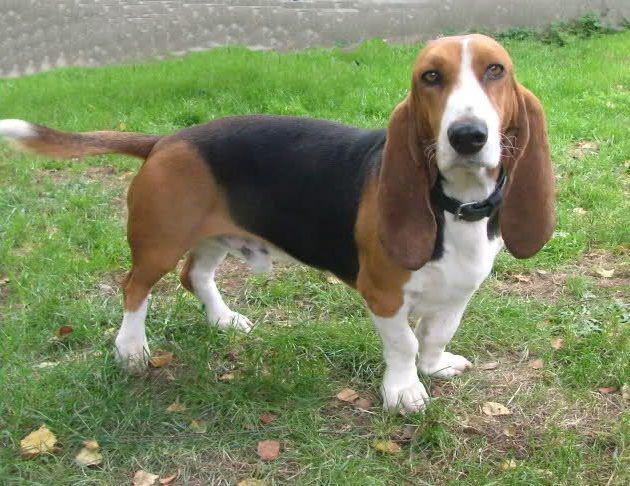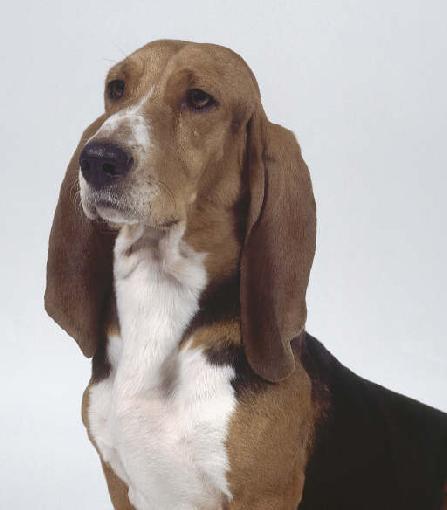The first image is the image on the left, the second image is the image on the right. Assess this claim about the two images: "there is a beagle outside on the grass". Correct or not? Answer yes or no. Yes. The first image is the image on the left, the second image is the image on the right. For the images displayed, is the sentence "Each image shows one standing basset hound, and one image includes a person with hands at the front and back of the dog." factually correct? Answer yes or no. No. 